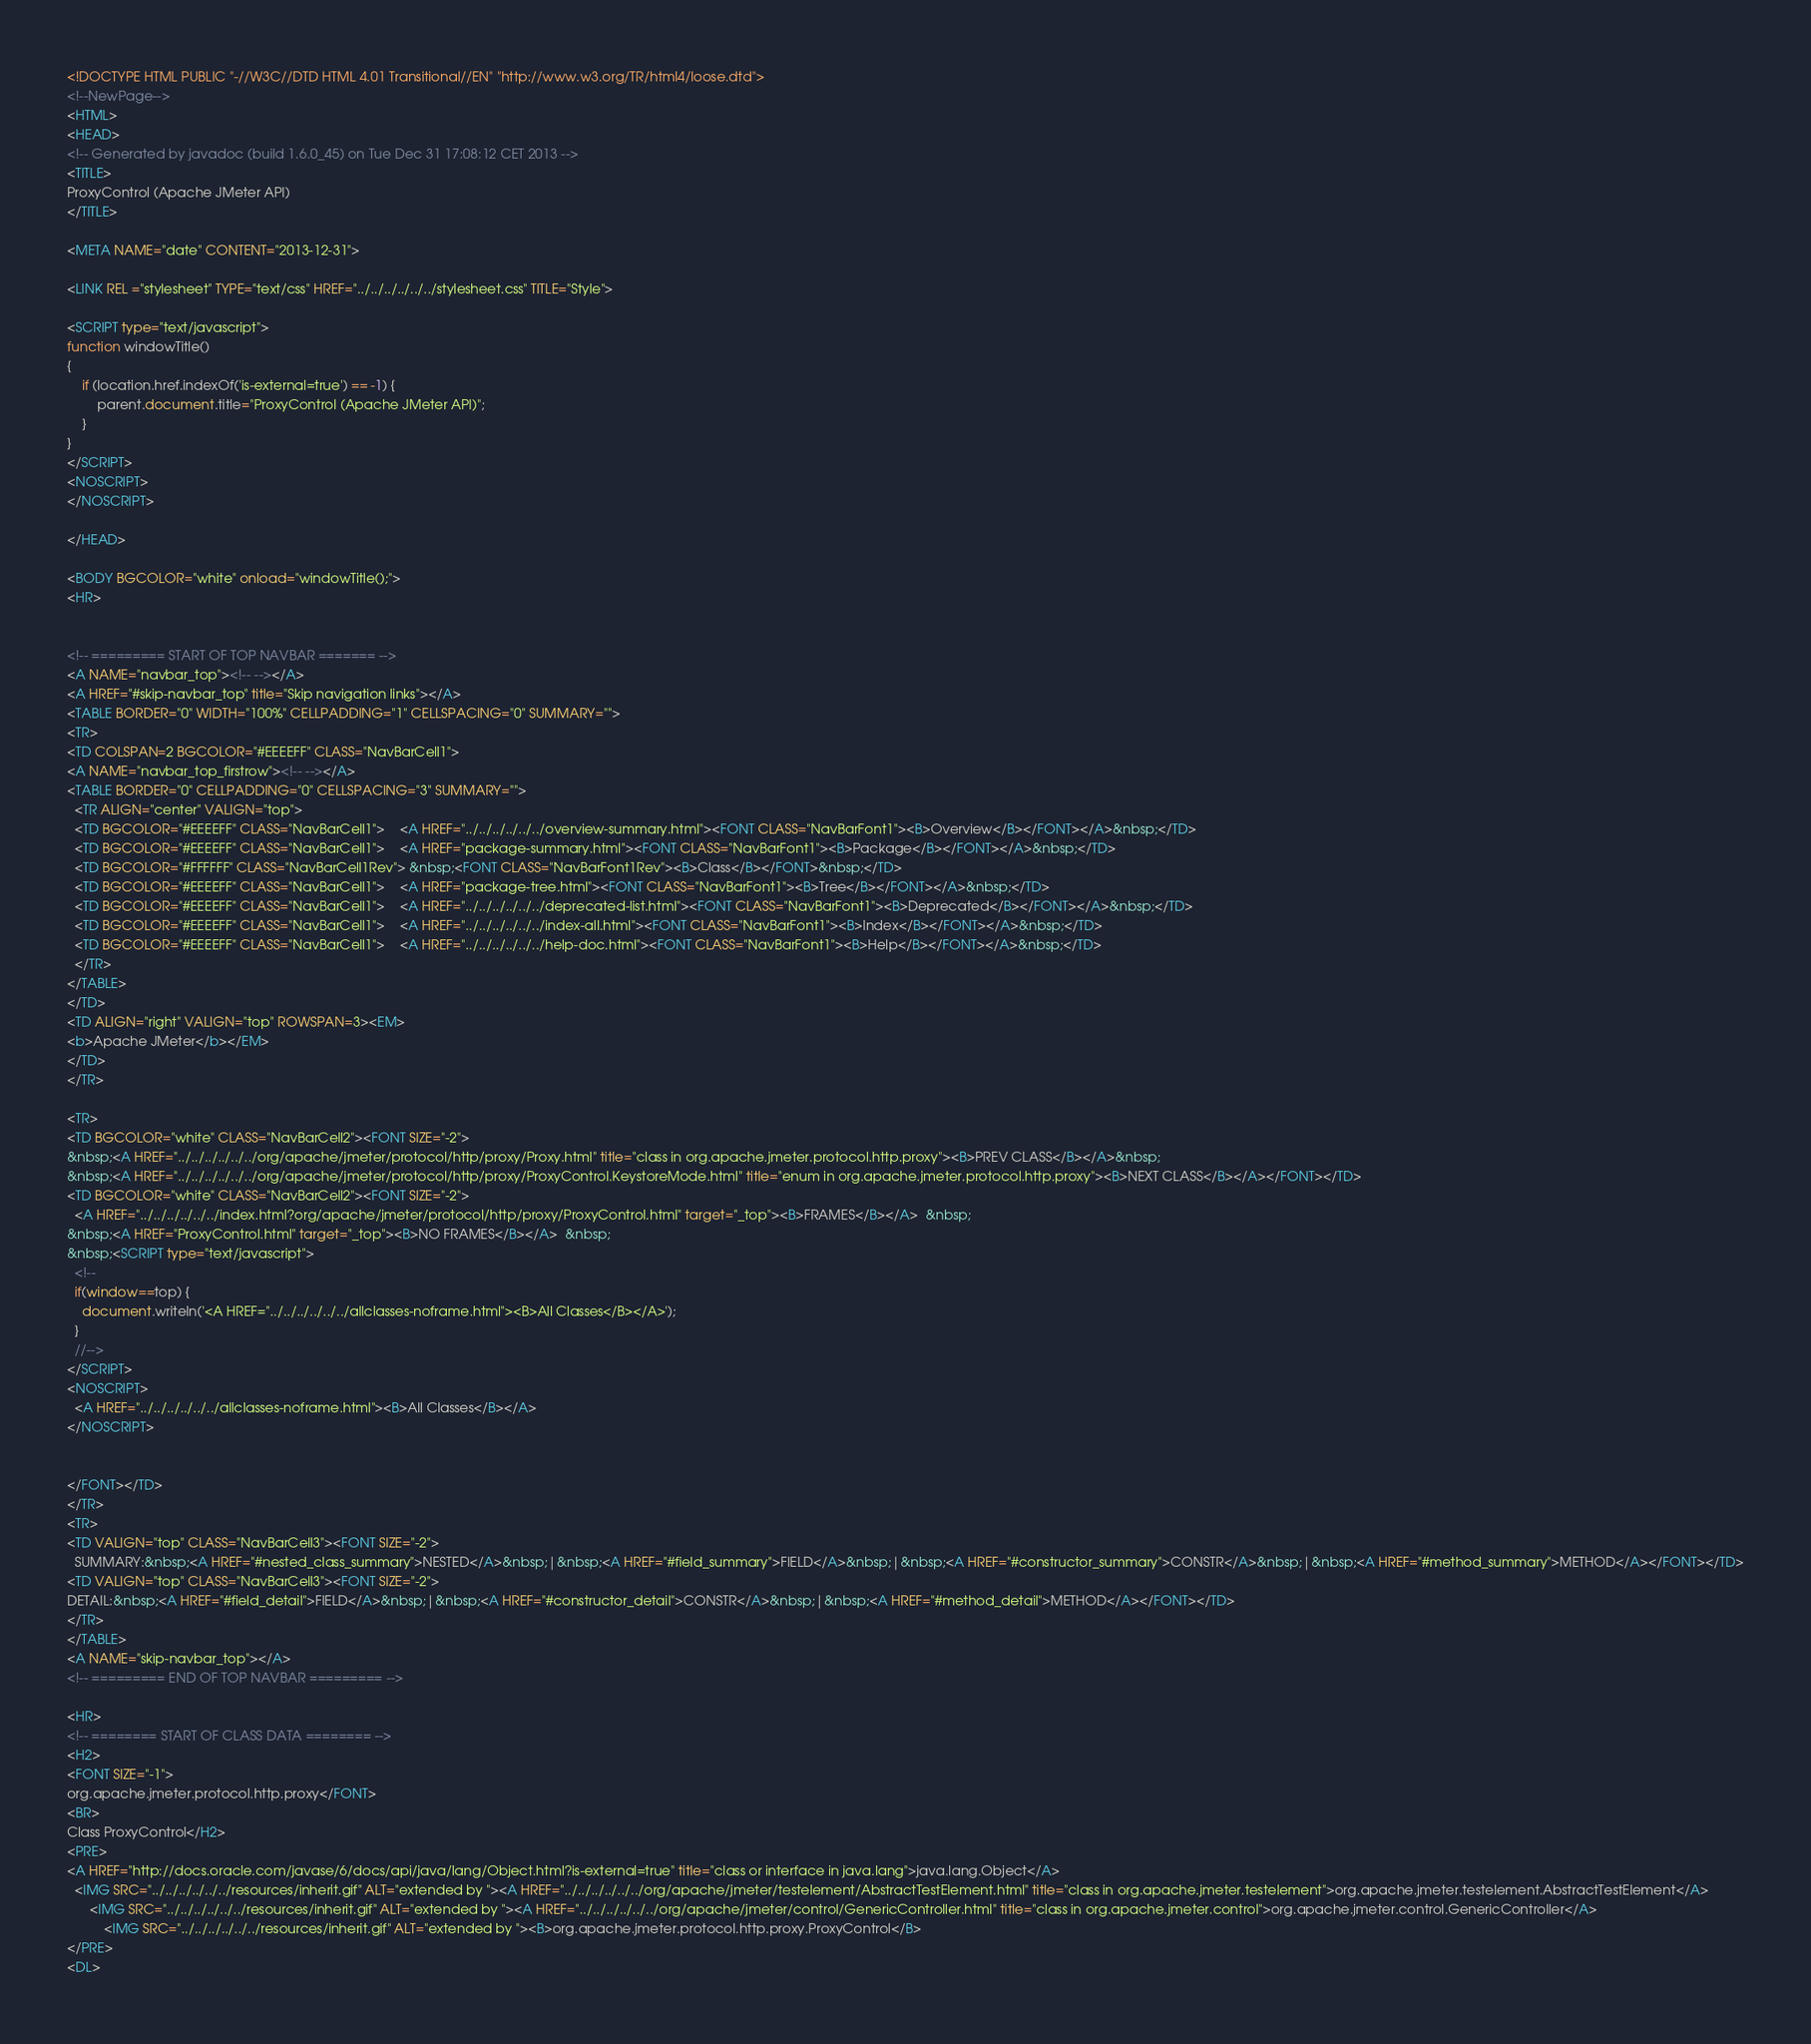<code> <loc_0><loc_0><loc_500><loc_500><_HTML_><!DOCTYPE HTML PUBLIC "-//W3C//DTD HTML 4.01 Transitional//EN" "http://www.w3.org/TR/html4/loose.dtd">
<!--NewPage-->
<HTML>
<HEAD>
<!-- Generated by javadoc (build 1.6.0_45) on Tue Dec 31 17:08:12 CET 2013 -->
<TITLE>
ProxyControl (Apache JMeter API)
</TITLE>

<META NAME="date" CONTENT="2013-12-31">

<LINK REL ="stylesheet" TYPE="text/css" HREF="../../../../../../stylesheet.css" TITLE="Style">

<SCRIPT type="text/javascript">
function windowTitle()
{
    if (location.href.indexOf('is-external=true') == -1) {
        parent.document.title="ProxyControl (Apache JMeter API)";
    }
}
</SCRIPT>
<NOSCRIPT>
</NOSCRIPT>

</HEAD>

<BODY BGCOLOR="white" onload="windowTitle();">
<HR>


<!-- ========= START OF TOP NAVBAR ======= -->
<A NAME="navbar_top"><!-- --></A>
<A HREF="#skip-navbar_top" title="Skip navigation links"></A>
<TABLE BORDER="0" WIDTH="100%" CELLPADDING="1" CELLSPACING="0" SUMMARY="">
<TR>
<TD COLSPAN=2 BGCOLOR="#EEEEFF" CLASS="NavBarCell1">
<A NAME="navbar_top_firstrow"><!-- --></A>
<TABLE BORDER="0" CELLPADDING="0" CELLSPACING="3" SUMMARY="">
  <TR ALIGN="center" VALIGN="top">
  <TD BGCOLOR="#EEEEFF" CLASS="NavBarCell1">    <A HREF="../../../../../../overview-summary.html"><FONT CLASS="NavBarFont1"><B>Overview</B></FONT></A>&nbsp;</TD>
  <TD BGCOLOR="#EEEEFF" CLASS="NavBarCell1">    <A HREF="package-summary.html"><FONT CLASS="NavBarFont1"><B>Package</B></FONT></A>&nbsp;</TD>
  <TD BGCOLOR="#FFFFFF" CLASS="NavBarCell1Rev"> &nbsp;<FONT CLASS="NavBarFont1Rev"><B>Class</B></FONT>&nbsp;</TD>
  <TD BGCOLOR="#EEEEFF" CLASS="NavBarCell1">    <A HREF="package-tree.html"><FONT CLASS="NavBarFont1"><B>Tree</B></FONT></A>&nbsp;</TD>
  <TD BGCOLOR="#EEEEFF" CLASS="NavBarCell1">    <A HREF="../../../../../../deprecated-list.html"><FONT CLASS="NavBarFont1"><B>Deprecated</B></FONT></A>&nbsp;</TD>
  <TD BGCOLOR="#EEEEFF" CLASS="NavBarCell1">    <A HREF="../../../../../../index-all.html"><FONT CLASS="NavBarFont1"><B>Index</B></FONT></A>&nbsp;</TD>
  <TD BGCOLOR="#EEEEFF" CLASS="NavBarCell1">    <A HREF="../../../../../../help-doc.html"><FONT CLASS="NavBarFont1"><B>Help</B></FONT></A>&nbsp;</TD>
  </TR>
</TABLE>
</TD>
<TD ALIGN="right" VALIGN="top" ROWSPAN=3><EM>
<b>Apache JMeter</b></EM>
</TD>
</TR>

<TR>
<TD BGCOLOR="white" CLASS="NavBarCell2"><FONT SIZE="-2">
&nbsp;<A HREF="../../../../../../org/apache/jmeter/protocol/http/proxy/Proxy.html" title="class in org.apache.jmeter.protocol.http.proxy"><B>PREV CLASS</B></A>&nbsp;
&nbsp;<A HREF="../../../../../../org/apache/jmeter/protocol/http/proxy/ProxyControl.KeystoreMode.html" title="enum in org.apache.jmeter.protocol.http.proxy"><B>NEXT CLASS</B></A></FONT></TD>
<TD BGCOLOR="white" CLASS="NavBarCell2"><FONT SIZE="-2">
  <A HREF="../../../../../../index.html?org/apache/jmeter/protocol/http/proxy/ProxyControl.html" target="_top"><B>FRAMES</B></A>  &nbsp;
&nbsp;<A HREF="ProxyControl.html" target="_top"><B>NO FRAMES</B></A>  &nbsp;
&nbsp;<SCRIPT type="text/javascript">
  <!--
  if(window==top) {
    document.writeln('<A HREF="../../../../../../allclasses-noframe.html"><B>All Classes</B></A>');
  }
  //-->
</SCRIPT>
<NOSCRIPT>
  <A HREF="../../../../../../allclasses-noframe.html"><B>All Classes</B></A>
</NOSCRIPT>


</FONT></TD>
</TR>
<TR>
<TD VALIGN="top" CLASS="NavBarCell3"><FONT SIZE="-2">
  SUMMARY:&nbsp;<A HREF="#nested_class_summary">NESTED</A>&nbsp;|&nbsp;<A HREF="#field_summary">FIELD</A>&nbsp;|&nbsp;<A HREF="#constructor_summary">CONSTR</A>&nbsp;|&nbsp;<A HREF="#method_summary">METHOD</A></FONT></TD>
<TD VALIGN="top" CLASS="NavBarCell3"><FONT SIZE="-2">
DETAIL:&nbsp;<A HREF="#field_detail">FIELD</A>&nbsp;|&nbsp;<A HREF="#constructor_detail">CONSTR</A>&nbsp;|&nbsp;<A HREF="#method_detail">METHOD</A></FONT></TD>
</TR>
</TABLE>
<A NAME="skip-navbar_top"></A>
<!-- ========= END OF TOP NAVBAR ========= -->

<HR>
<!-- ======== START OF CLASS DATA ======== -->
<H2>
<FONT SIZE="-1">
org.apache.jmeter.protocol.http.proxy</FONT>
<BR>
Class ProxyControl</H2>
<PRE>
<A HREF="http://docs.oracle.com/javase/6/docs/api/java/lang/Object.html?is-external=true" title="class or interface in java.lang">java.lang.Object</A>
  <IMG SRC="../../../../../../resources/inherit.gif" ALT="extended by "><A HREF="../../../../../../org/apache/jmeter/testelement/AbstractTestElement.html" title="class in org.apache.jmeter.testelement">org.apache.jmeter.testelement.AbstractTestElement</A>
      <IMG SRC="../../../../../../resources/inherit.gif" ALT="extended by "><A HREF="../../../../../../org/apache/jmeter/control/GenericController.html" title="class in org.apache.jmeter.control">org.apache.jmeter.control.GenericController</A>
          <IMG SRC="../../../../../../resources/inherit.gif" ALT="extended by "><B>org.apache.jmeter.protocol.http.proxy.ProxyControl</B>
</PRE>
<DL></code> 